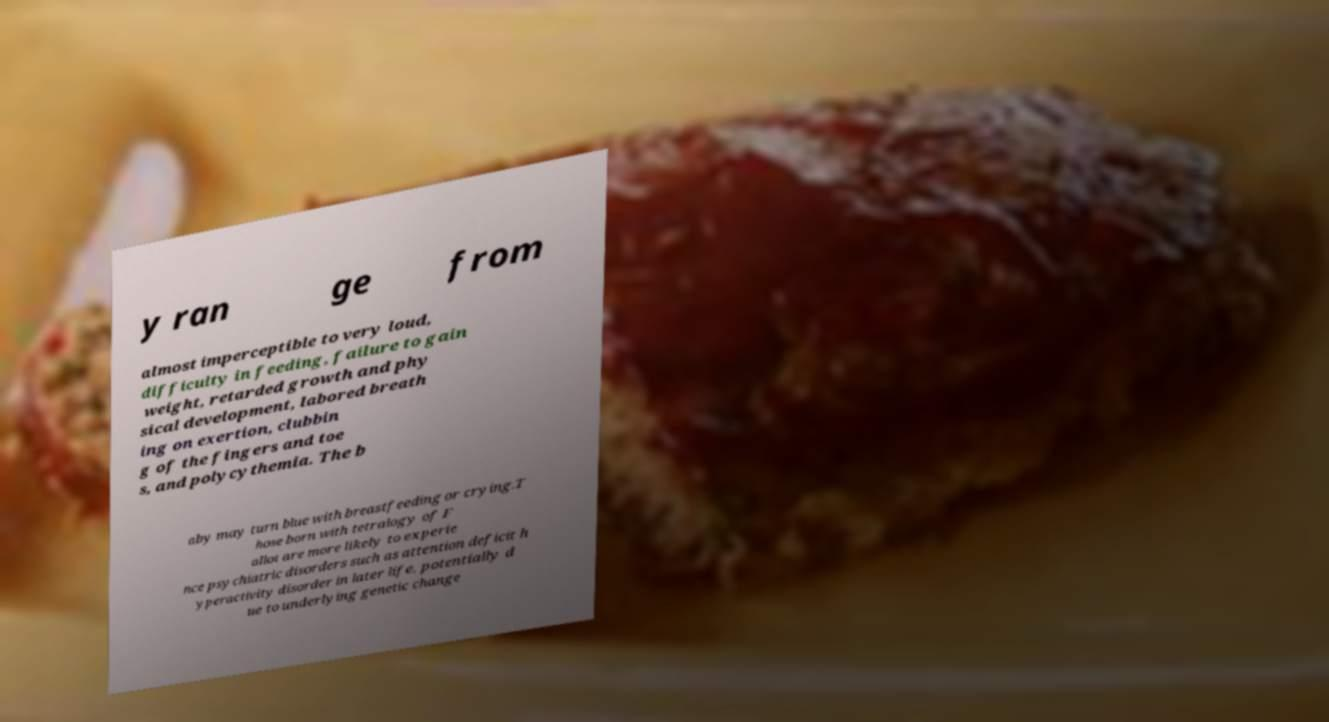Can you read and provide the text displayed in the image?This photo seems to have some interesting text. Can you extract and type it out for me? y ran ge from almost imperceptible to very loud, difficulty in feeding, failure to gain weight, retarded growth and phy sical development, labored breath ing on exertion, clubbin g of the fingers and toe s, and polycythemia. The b aby may turn blue with breastfeeding or crying.T hose born with tetralogy of F allot are more likely to experie nce psychiatric disorders such as attention deficit h yperactivity disorder in later life, potentially d ue to underlying genetic change 